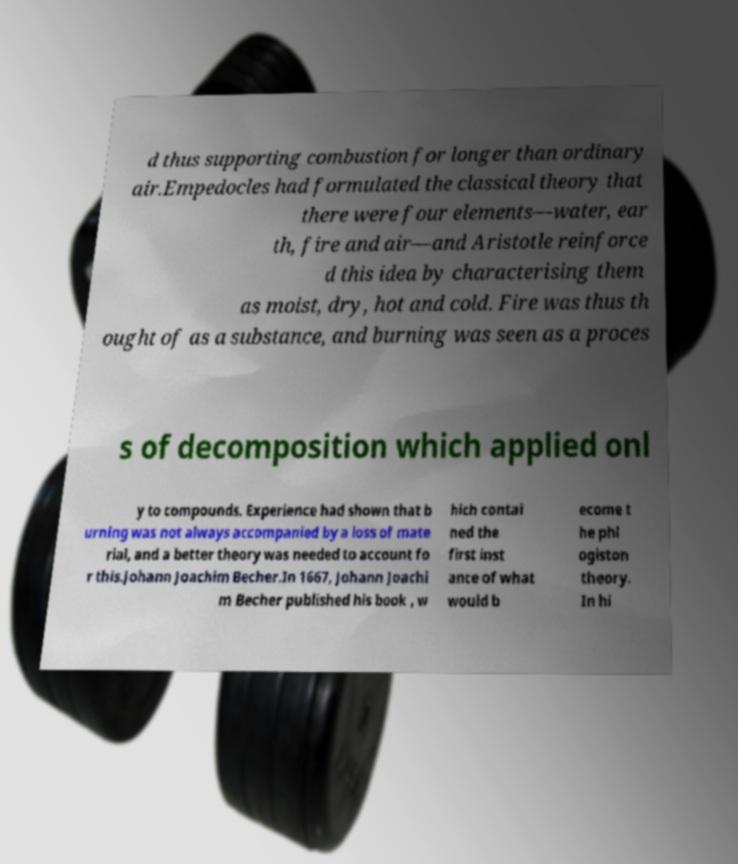There's text embedded in this image that I need extracted. Can you transcribe it verbatim? d thus supporting combustion for longer than ordinary air.Empedocles had formulated the classical theory that there were four elements—water, ear th, fire and air—and Aristotle reinforce d this idea by characterising them as moist, dry, hot and cold. Fire was thus th ought of as a substance, and burning was seen as a proces s of decomposition which applied onl y to compounds. Experience had shown that b urning was not always accompanied by a loss of mate rial, and a better theory was needed to account fo r this.Johann Joachim Becher.In 1667, Johann Joachi m Becher published his book , w hich contai ned the first inst ance of what would b ecome t he phl ogiston theory. In hi 